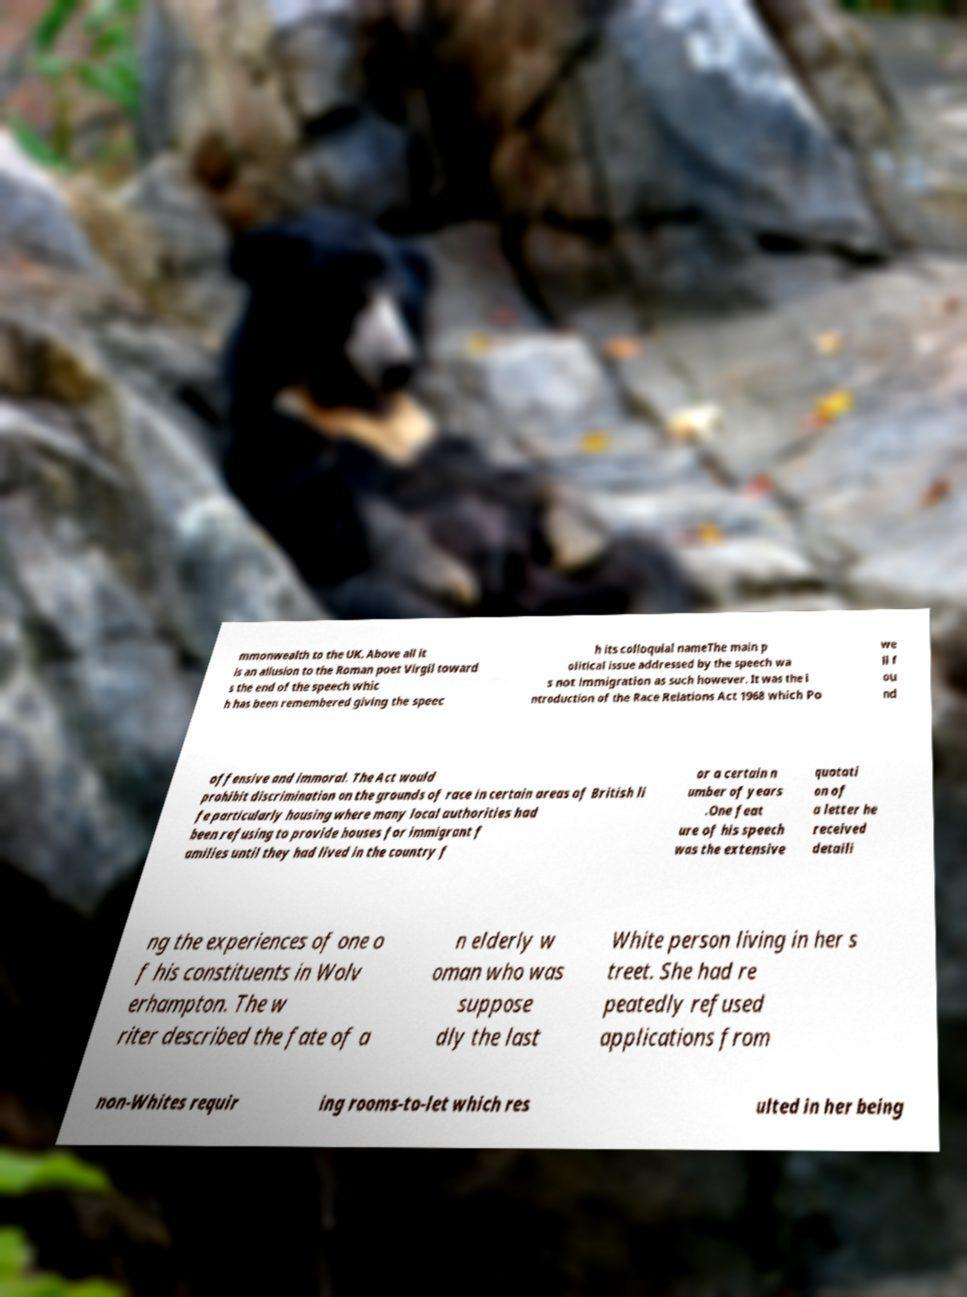There's text embedded in this image that I need extracted. Can you transcribe it verbatim? mmonwealth to the UK. Above all it is an allusion to the Roman poet Virgil toward s the end of the speech whic h has been remembered giving the speec h its colloquial nameThe main p olitical issue addressed by the speech wa s not immigration as such however. It was the i ntroduction of the Race Relations Act 1968 which Po we ll f ou nd offensive and immoral. The Act would prohibit discrimination on the grounds of race in certain areas of British li fe particularly housing where many local authorities had been refusing to provide houses for immigrant f amilies until they had lived in the country f or a certain n umber of years .One feat ure of his speech was the extensive quotati on of a letter he received detaili ng the experiences of one o f his constituents in Wolv erhampton. The w riter described the fate of a n elderly w oman who was suppose dly the last White person living in her s treet. She had re peatedly refused applications from non-Whites requir ing rooms-to-let which res ulted in her being 